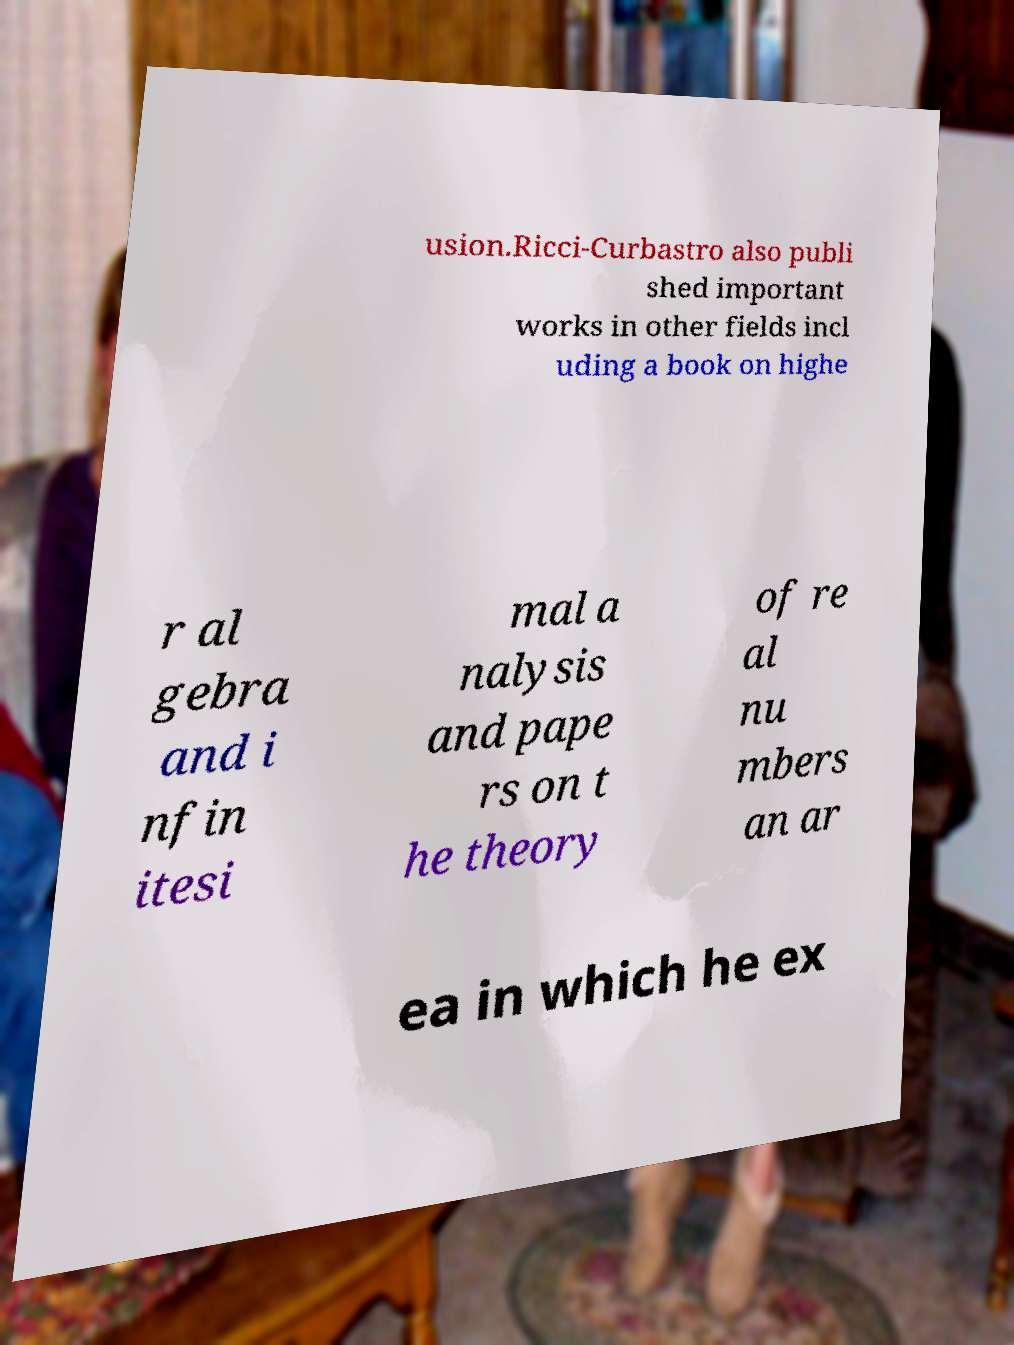There's text embedded in this image that I need extracted. Can you transcribe it verbatim? usion.Ricci-Curbastro also publi shed important works in other fields incl uding a book on highe r al gebra and i nfin itesi mal a nalysis and pape rs on t he theory of re al nu mbers an ar ea in which he ex 